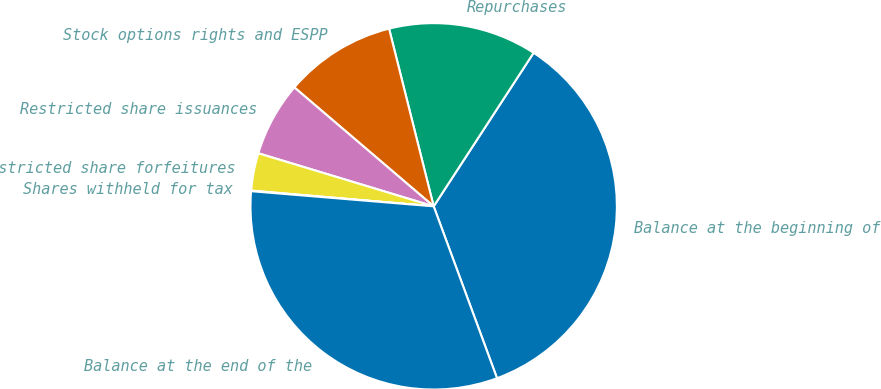Convert chart to OTSL. <chart><loc_0><loc_0><loc_500><loc_500><pie_chart><fcel>Balance at the beginning of<fcel>Repurchases<fcel>Stock options rights and ESPP<fcel>Restricted share issuances<fcel>Restricted share forfeitures<fcel>Shares withheld for tax<fcel>Balance at the end of the<nl><fcel>35.2%<fcel>13.1%<fcel>9.84%<fcel>6.57%<fcel>3.31%<fcel>0.05%<fcel>31.94%<nl></chart> 